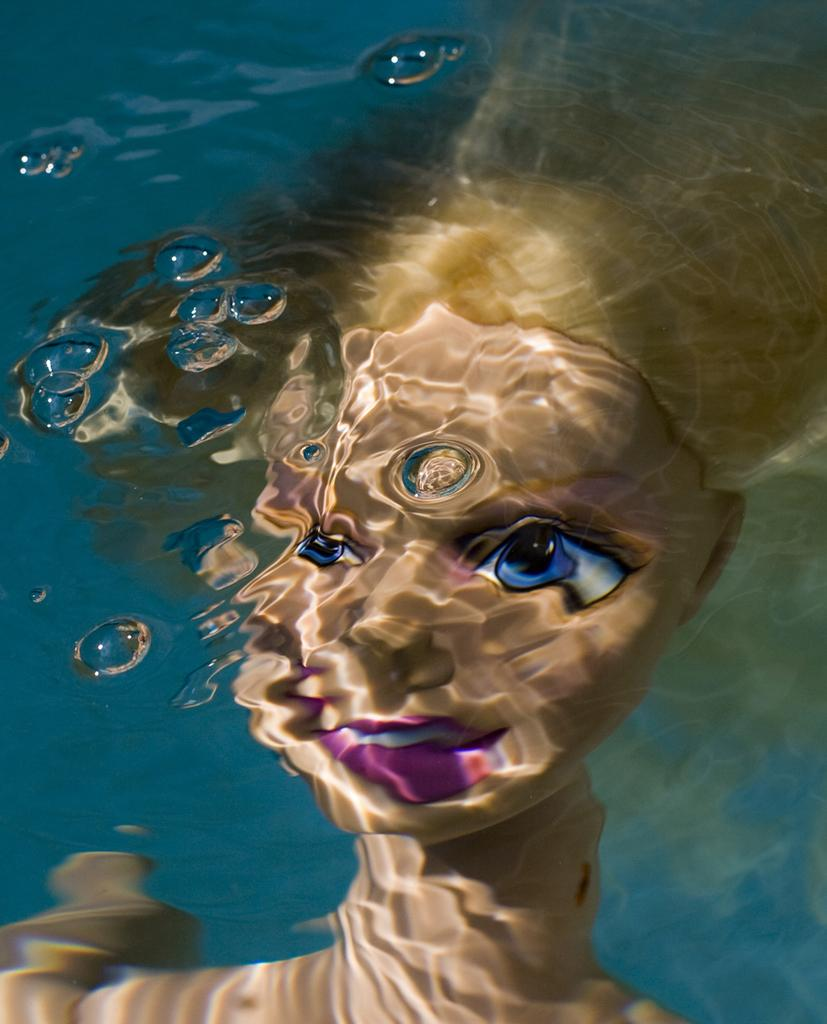What is in the water in the image? There is a doll in the water. What type of lead can be seen in the image? There is no lead present in the image; it features a doll in the water. How many snails can be seen in the image? There are no snails present in the image; it features a doll in the water. 